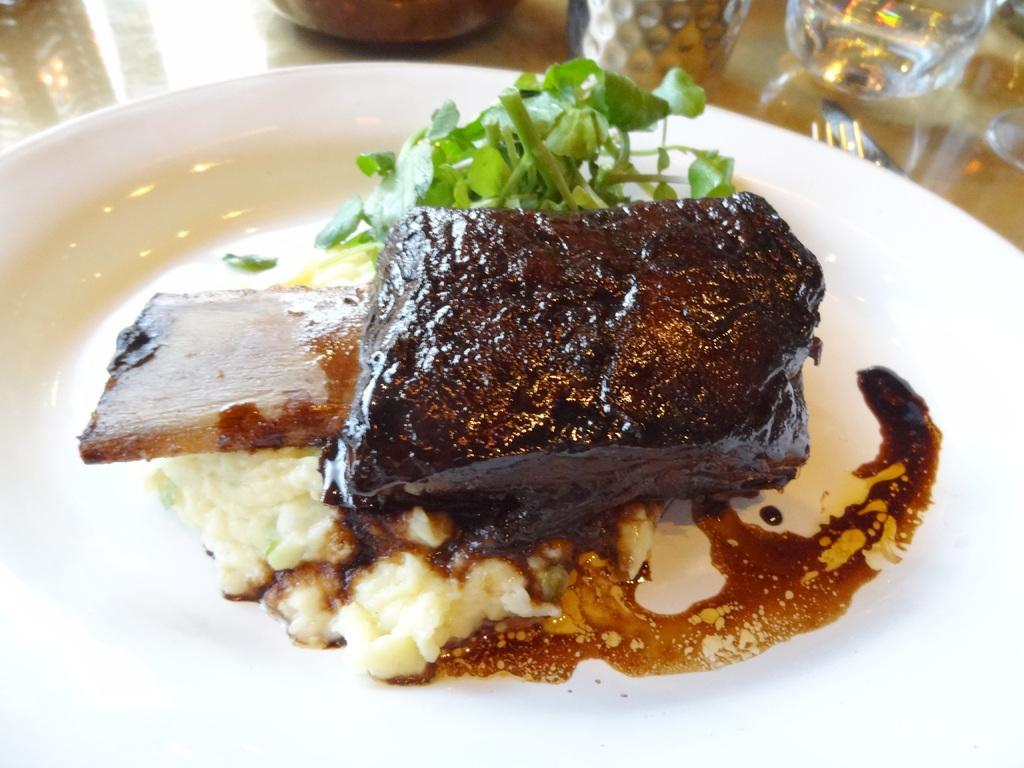Please provide a concise description of this image. In the foreground of this image, there is some food and leafy vegetables on a white platter. At the top, it seems like glasses, fork, knife and an object on the surface. 